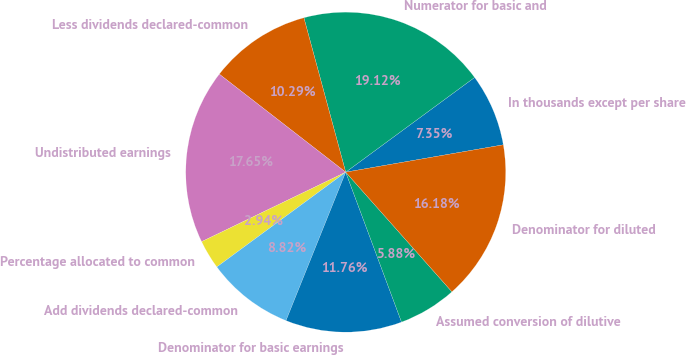Convert chart to OTSL. <chart><loc_0><loc_0><loc_500><loc_500><pie_chart><fcel>In thousands except per share<fcel>Numerator for basic and<fcel>Less dividends declared-common<fcel>Undistributed earnings<fcel>Percentage allocated to common<fcel>Add dividends declared-common<fcel>Denominator for basic earnings<fcel>Assumed conversion of dilutive<fcel>Denominator for diluted<nl><fcel>7.35%<fcel>19.12%<fcel>10.29%<fcel>17.65%<fcel>2.94%<fcel>8.82%<fcel>11.76%<fcel>5.88%<fcel>16.18%<nl></chart> 